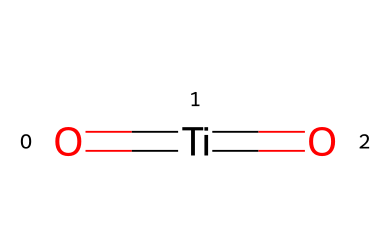What is the name of this chemical? The SMILES representation reveals a titanium atom bonded to two oxygen atoms through double bonds. This compound is commonly known as Titanium Dioxide.
Answer: Titanium Dioxide How many oxygen atoms are present in the molecule? The SMILES notation shows that two oxygen atoms are bonded to a titanium atom. Therefore, there are two oxygen atoms present in the structure.
Answer: 2 What type of chemical bonds are present in this compound? The SMILES representation indicates double bonds between the titanium and the oxygen atoms. Thus, the type of chemical bonds in this compound is double bonds.
Answer: double bonds What is the oxidation state of the titanium in this molecule? In Titanium Dioxide, titanium typically exhibits a +4 oxidation state due to its bonding with two oxide ions (O2-), which each carry a -2 charge. Therefore, the overall charge balance confirms titanium's +4 state.
Answer: +4 How is Titanium Dioxide used in cosmetics? This compound functions as a UV filter, effectively blocking harmful ultraviolet rays. Its structural properties and stability make it suitable as an active ingredient in sunscreens and other cosmetic products.
Answer: UV filter What is one notable property of Titanium Dioxide in relation to sunlight? Titanium Dioxide is well known for its strong UV light absorption capabilities, making it effective in protecting the skin from harmful UV radiation when used in sunscreens.
Answer: UV absorption 